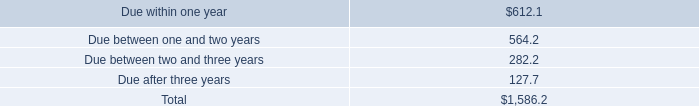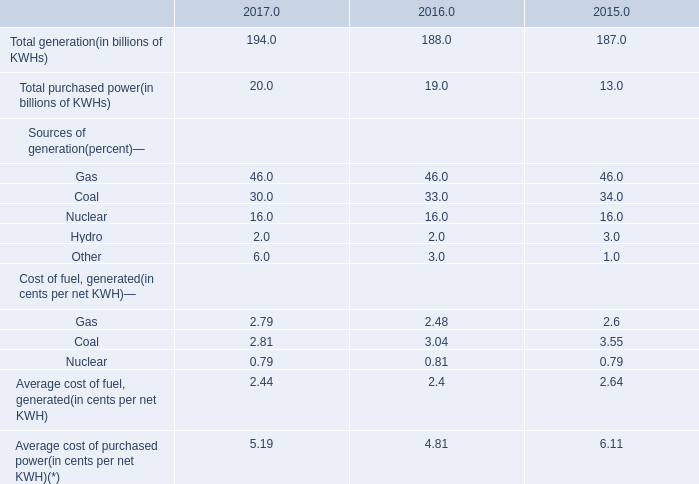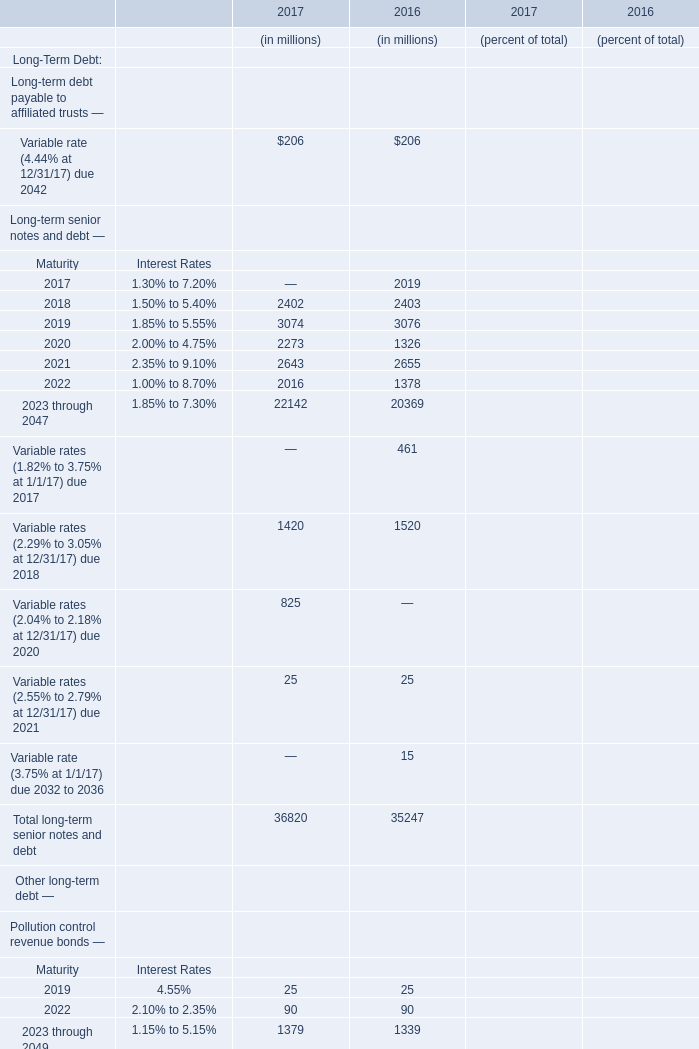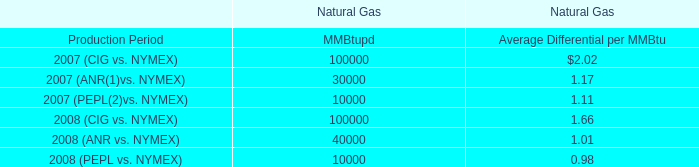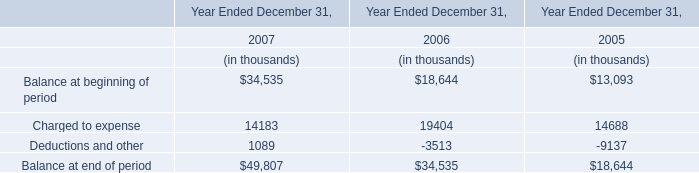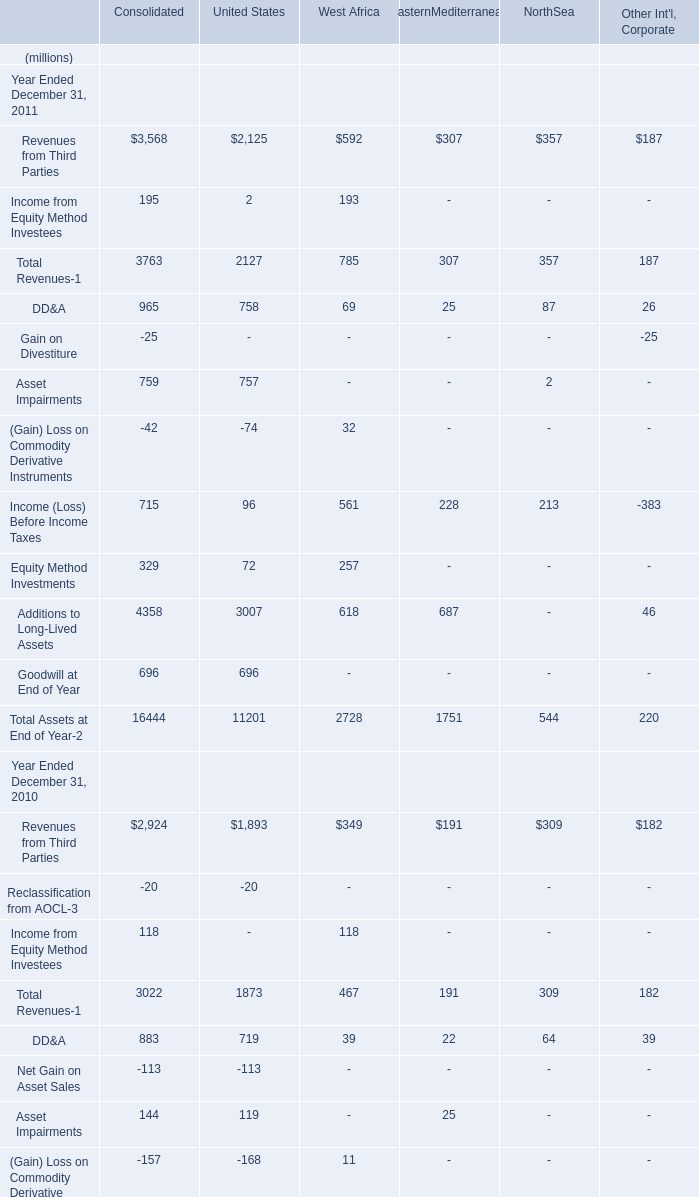What was the total amount of EasternMediterranean excluding those EasternMediterranean greater than 100 in 2010? (in million) 
Computations: (((22 + 25) + 20) + 98)
Answer: 165.0. 